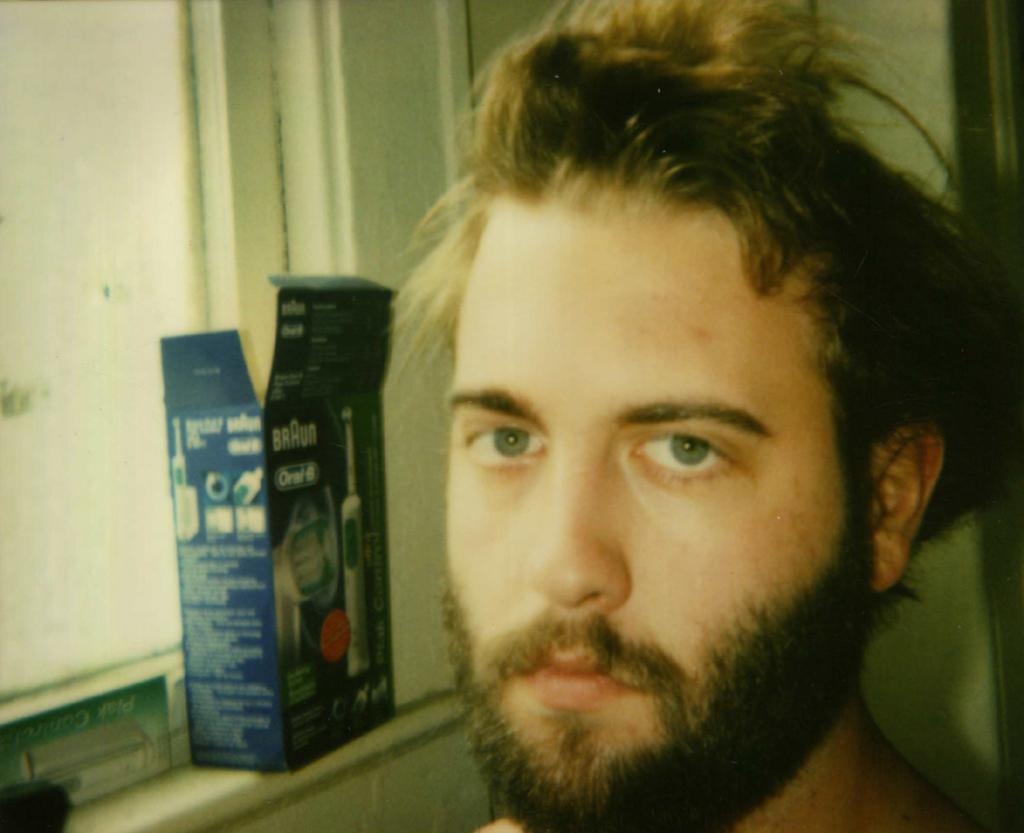Who is present in the image? There is a man in the image. Can you describe the man's facial hair? The man has a mustache and beard. What object related to dental hygiene can be seen in the image? There is a toothbrush box in the image. What can be seen on the left side of the image? There is a window on the left side of the image. What is visible in the background of the image? There is a wall in the background of the image. What type of hat is the man wearing in the image? The man is not wearing a hat in the image. Can you describe the desk that the man is sitting at in the image? There is no desk present in the image. 